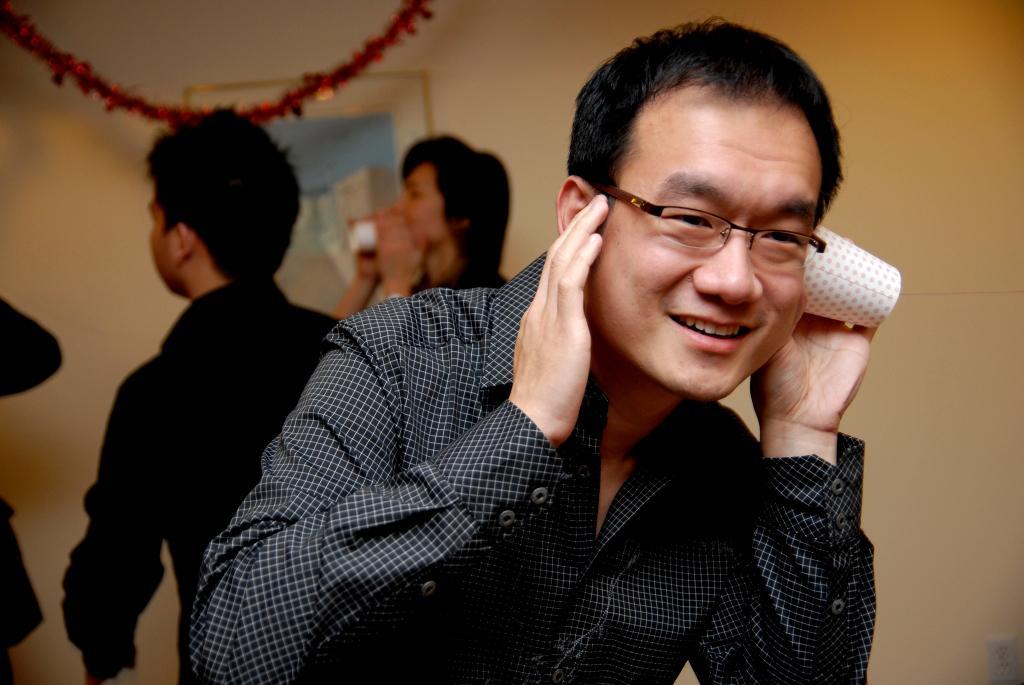Describe this image in one or two sentences. In this image there are men, they are holding an object, at the top of the image there is an object that looks like a decorative ribbon, at the background of the image there is the wall, there is a photo frame on the wall. 